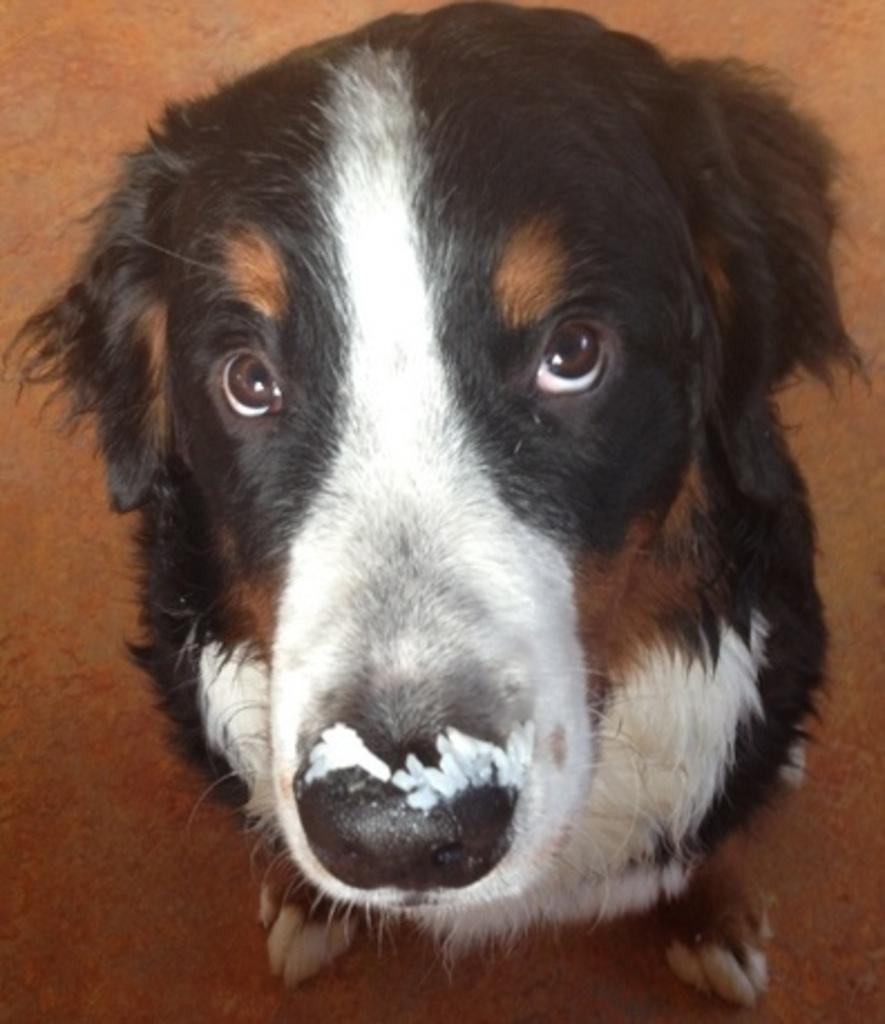Describe this image in one or two sentences. In this picture there is a brown color dog sitting in the front and looking to the camera. Behind there is a brown carpet flooring. 